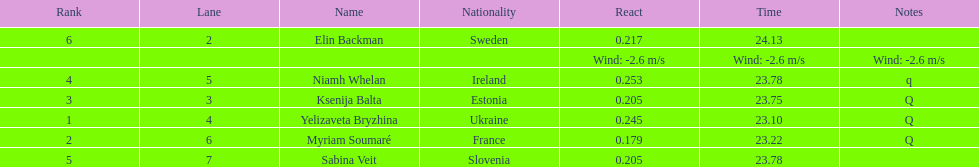Who is the first ranking player? Yelizaveta Bryzhina. 